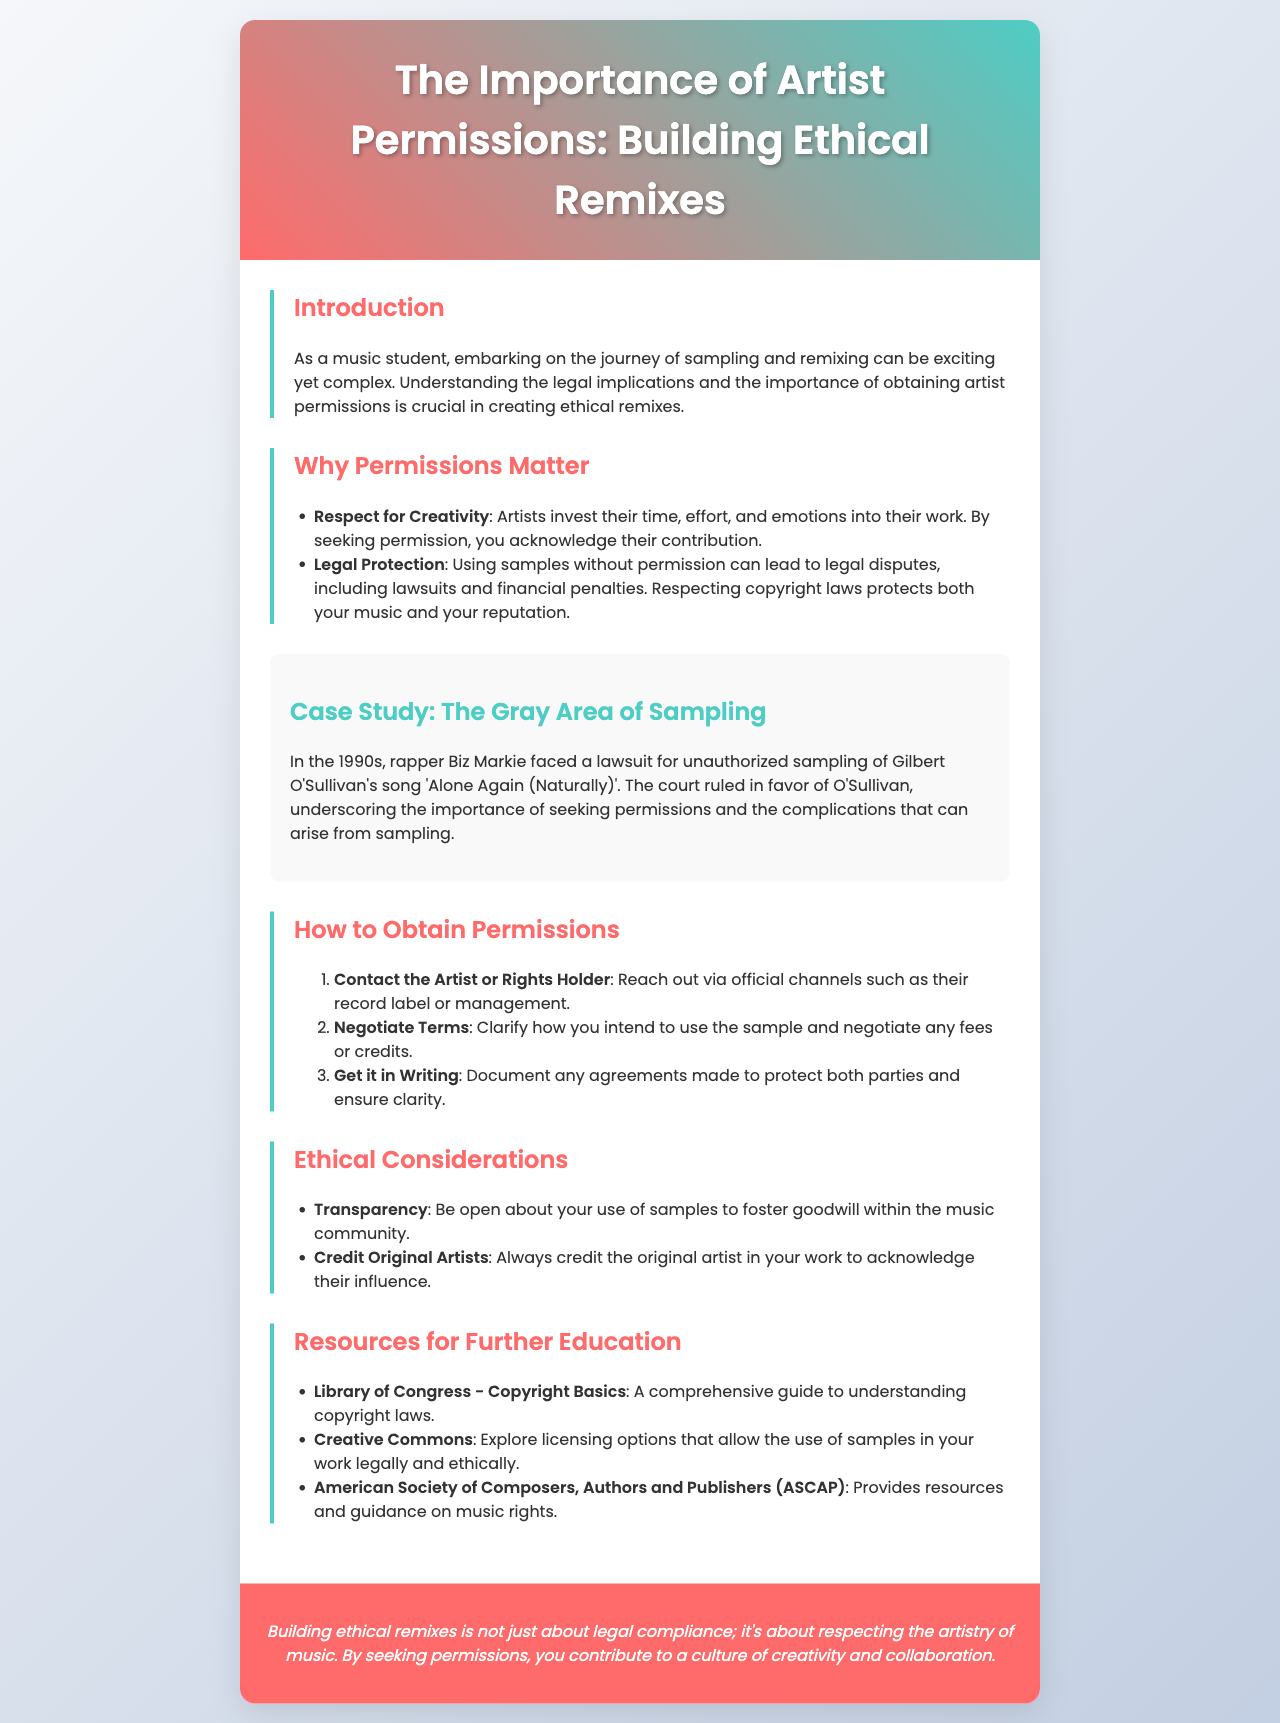What is the title of the brochure? The title of the brochure appears prominently at the top of the document.
Answer: The Importance of Artist Permissions: Building Ethical Remixes What is one reason why permissions matter? This question can be answered by looking at the list of reasons provided in the document under the "Why Permissions Matter" section.
Answer: Respect for Creativity What case is mentioned in the case study? The case study section discusses a specific lawsuit related to sampling.
Answer: Biz Markie Who faced a lawsuit for unauthorized sampling? The case study highlights a specific artist involved in a legal dispute.
Answer: Biz Markie What should you do to obtain permissions? The brochure provides steps to legally obtain permissions for samples.
Answer: Contact the Artist or Rights Holder What is a key ethical consideration when remixing? The section on ethical considerations lists important principles for ethical sampling and remixing.
Answer: Transparency Name one resource for further education mentioned in the brochure. The document lists various resources for understanding music rights and copyright laws.
Answer: Library of Congress - Copyright Basics How should original artists be credited? The ethical considerations section states how to acknowledge original artists in your work.
Answer: Always credit the original artist What legal consequence can arise from unauthorized sampling? This is directly discussed in the "Why Permissions Matter" section.
Answer: Legal disputes 